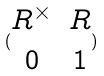<formula> <loc_0><loc_0><loc_500><loc_500>( \begin{matrix} R ^ { \times } & R \\ 0 & 1 \end{matrix} )</formula> 